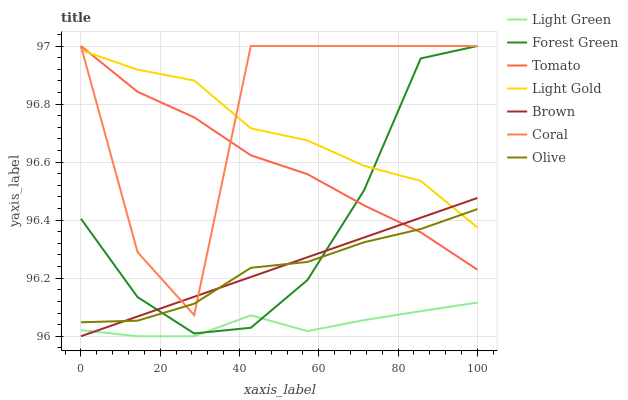Does Light Green have the minimum area under the curve?
Answer yes or no. Yes. Does Coral have the maximum area under the curve?
Answer yes or no. Yes. Does Brown have the minimum area under the curve?
Answer yes or no. No. Does Brown have the maximum area under the curve?
Answer yes or no. No. Is Brown the smoothest?
Answer yes or no. Yes. Is Coral the roughest?
Answer yes or no. Yes. Is Coral the smoothest?
Answer yes or no. No. Is Brown the roughest?
Answer yes or no. No. Does Brown have the lowest value?
Answer yes or no. Yes. Does Coral have the lowest value?
Answer yes or no. No. Does Forest Green have the highest value?
Answer yes or no. Yes. Does Brown have the highest value?
Answer yes or no. No. Is Light Green less than Olive?
Answer yes or no. Yes. Is Olive greater than Light Green?
Answer yes or no. Yes. Does Olive intersect Coral?
Answer yes or no. Yes. Is Olive less than Coral?
Answer yes or no. No. Is Olive greater than Coral?
Answer yes or no. No. Does Light Green intersect Olive?
Answer yes or no. No. 